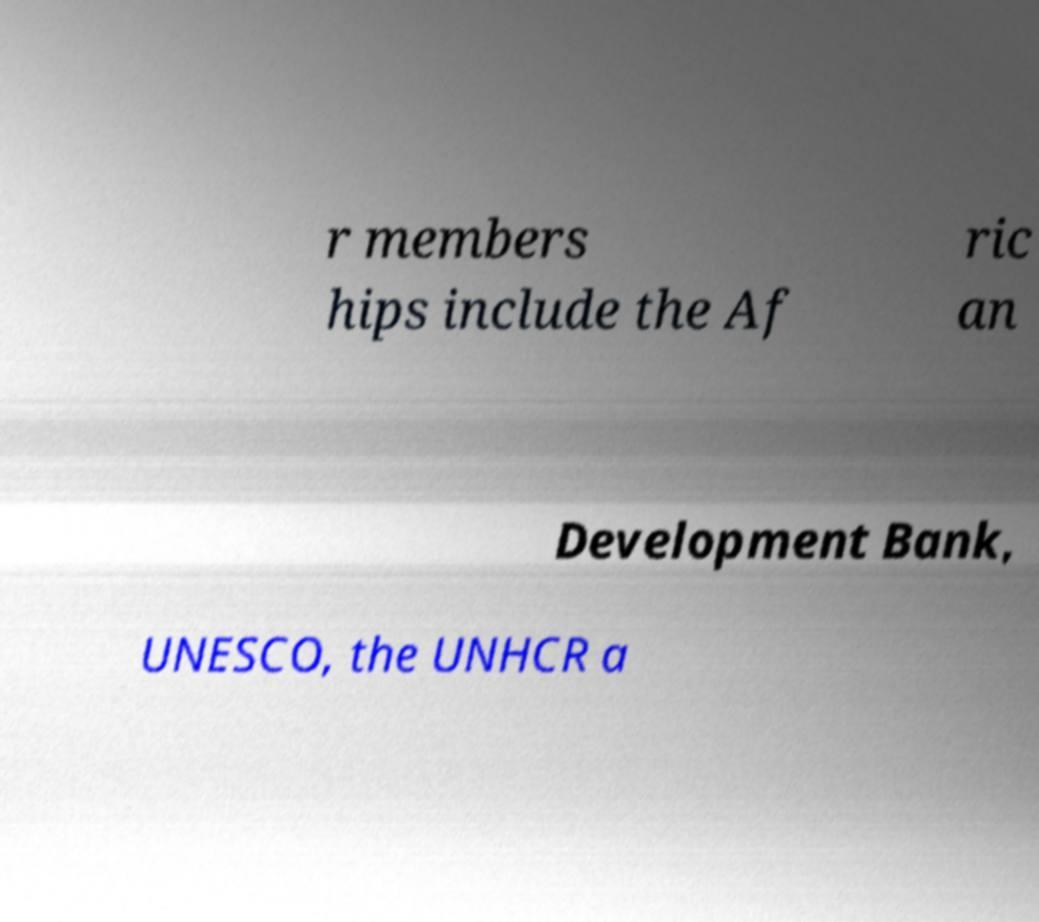For documentation purposes, I need the text within this image transcribed. Could you provide that? r members hips include the Af ric an Development Bank, UNESCO, the UNHCR a 